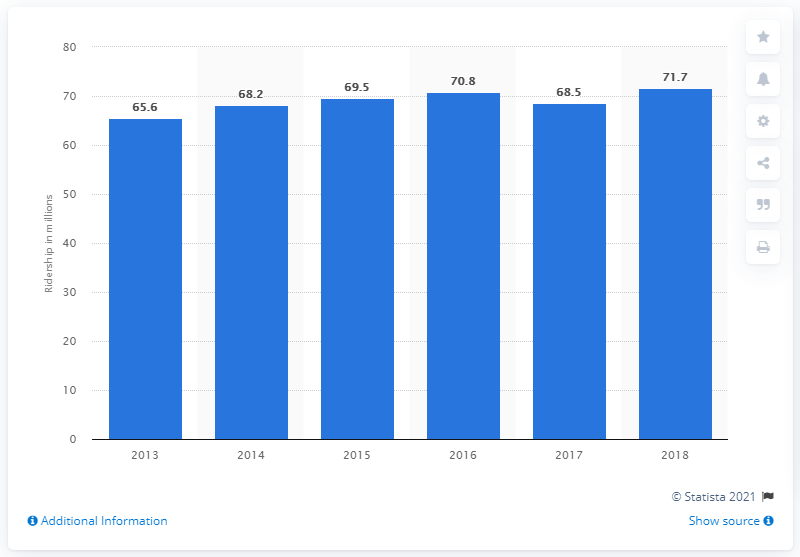Point out several critical features in this image. In 2018, GO Transit's regional public transit system was used by 71.7% of the people who lived in the areas it served. 